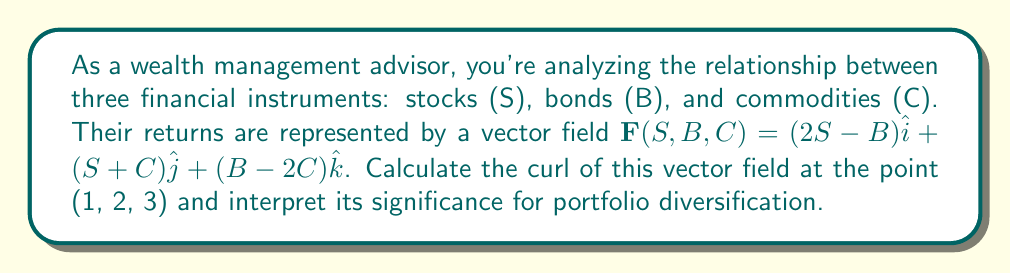Help me with this question. To solve this problem, we'll follow these steps:

1) Recall the formula for curl in 3D:
   $$\text{curl }\mathbf{F} = \nabla \times \mathbf{F} = \left(\frac{\partial F_z}{\partial B} - \frac{\partial F_y}{\partial C}\right)\hat{i} + \left(\frac{\partial F_x}{\partial C} - \frac{\partial F_z}{\partial S}\right)\hat{j} + \left(\frac{\partial F_y}{\partial S} - \frac{\partial F_x}{\partial B}\right)\hat{k}$$

2) Identify the components of $\mathbf{F}$:
   $F_x = 2S-B$
   $F_y = S+C$
   $F_z = B-2C$

3) Calculate the partial derivatives:
   $\frac{\partial F_z}{\partial B} = 1$
   $\frac{\partial F_y}{\partial C} = 1$
   $\frac{\partial F_x}{\partial C} = 0$
   $\frac{\partial F_z}{\partial S} = 0$
   $\frac{\partial F_y}{\partial S} = 1$
   $\frac{\partial F_x}{\partial B} = -1$

4) Substitute these values into the curl formula:
   $$\text{curl }\mathbf{F} = (1-1)\hat{i} + (0-0)\hat{j} + (1-(-1))\hat{k} = 2\hat{k}$$

5) The curl is constant and doesn't depend on the point, so it's the same at (1, 2, 3).

Interpretation: The non-zero curl indicates a rotational component in the relationship between these financial instruments. Specifically, the positive $k$ component suggests a tendency for the returns to rotate in the S-B plane. This implies that as stock returns increase, bond returns tend to decrease, and vice versa, which is consistent with the typical negative correlation between stocks and bonds. The magnitude of 2 indicates the strength of this relationship. For portfolio diversification, this suggests that combining stocks and bonds could provide a hedging effect, potentially reducing overall portfolio risk.
Answer: $2\hat{k}$ 